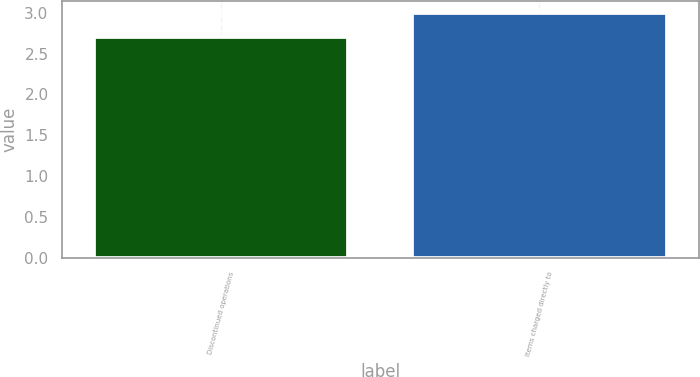Convert chart to OTSL. <chart><loc_0><loc_0><loc_500><loc_500><bar_chart><fcel>Discontinued operations<fcel>Items charged directly to<nl><fcel>2.7<fcel>3<nl></chart> 